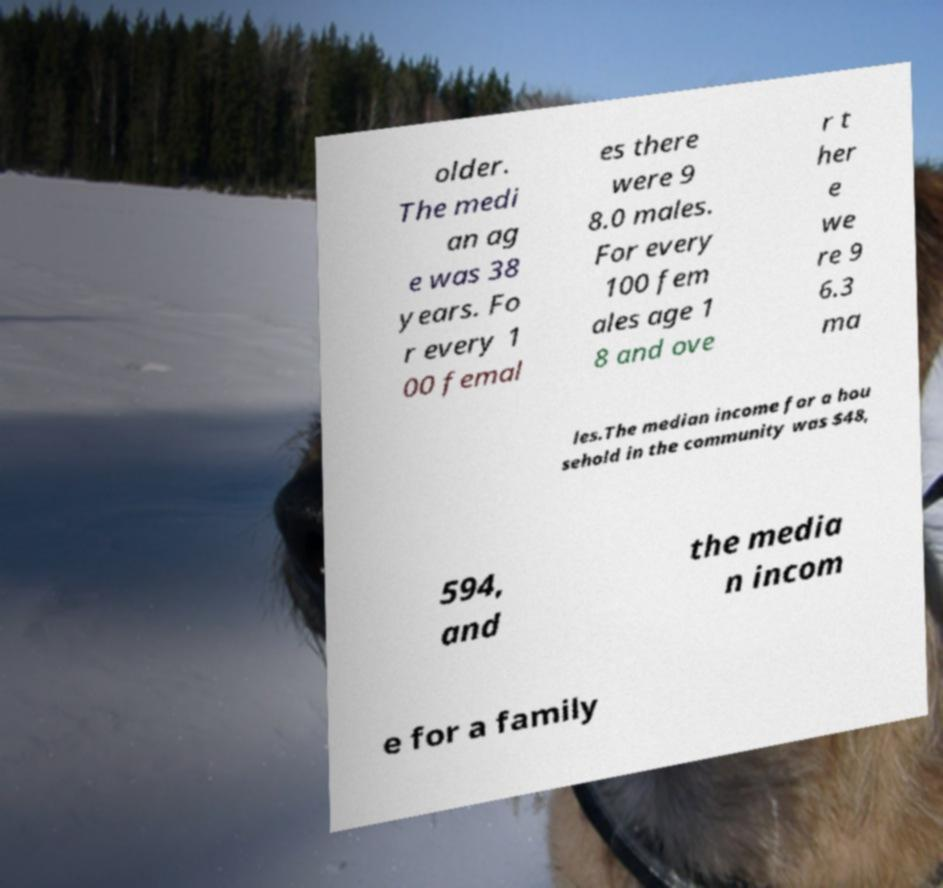Can you read and provide the text displayed in the image?This photo seems to have some interesting text. Can you extract and type it out for me? older. The medi an ag e was 38 years. Fo r every 1 00 femal es there were 9 8.0 males. For every 100 fem ales age 1 8 and ove r t her e we re 9 6.3 ma les.The median income for a hou sehold in the community was $48, 594, and the media n incom e for a family 